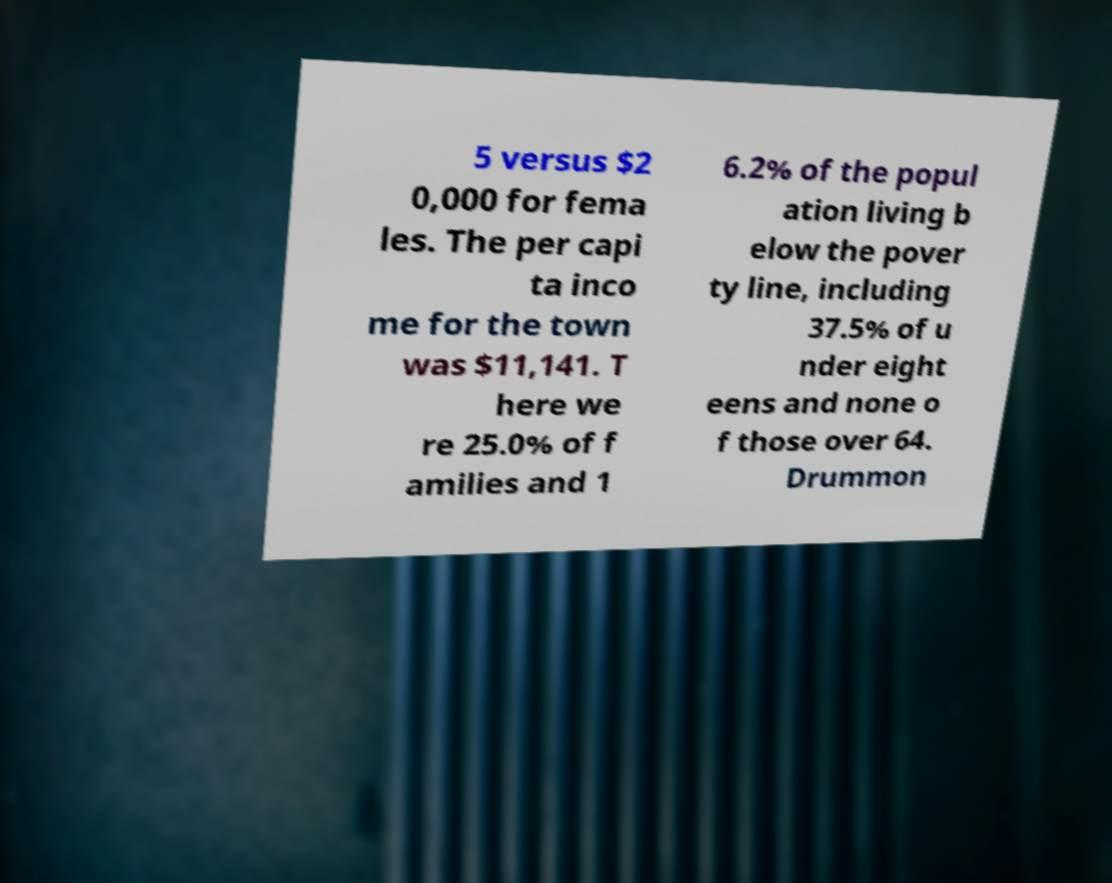Can you read and provide the text displayed in the image?This photo seems to have some interesting text. Can you extract and type it out for me? 5 versus $2 0,000 for fema les. The per capi ta inco me for the town was $11,141. T here we re 25.0% of f amilies and 1 6.2% of the popul ation living b elow the pover ty line, including 37.5% of u nder eight eens and none o f those over 64. Drummon 